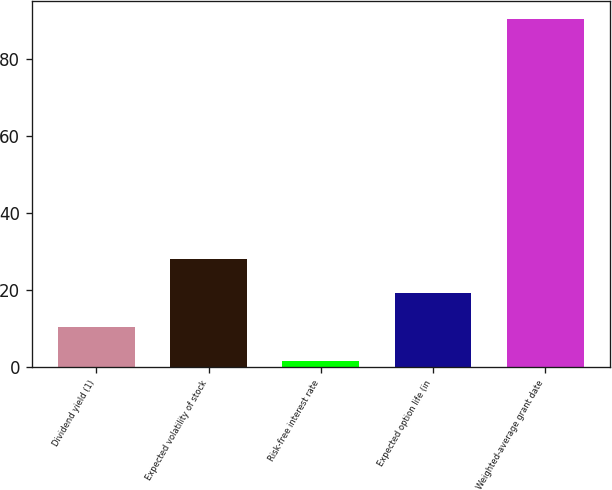Convert chart. <chart><loc_0><loc_0><loc_500><loc_500><bar_chart><fcel>Dividend yield (1)<fcel>Expected volatility of stock<fcel>Risk-free interest rate<fcel>Expected option life (in<fcel>Weighted-average grant date<nl><fcel>10.4<fcel>28.2<fcel>1.5<fcel>19.3<fcel>90.51<nl></chart> 